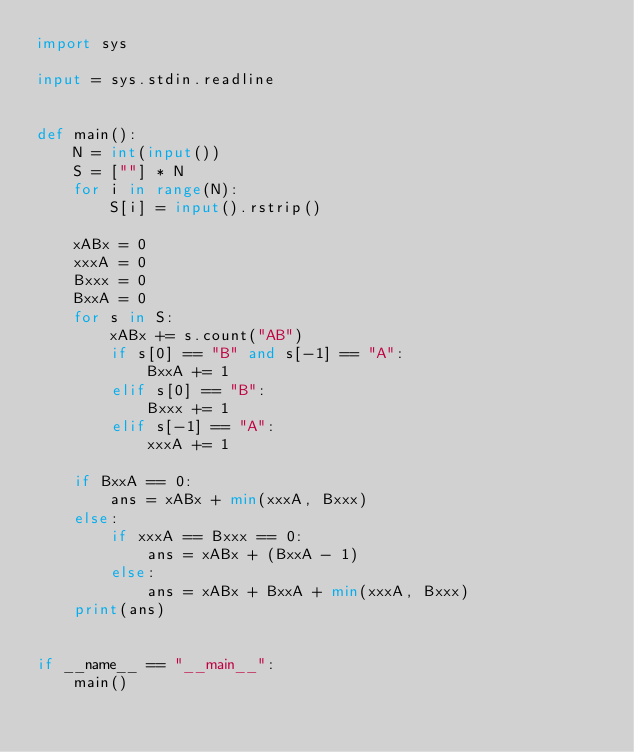<code> <loc_0><loc_0><loc_500><loc_500><_Python_>import sys

input = sys.stdin.readline


def main():
    N = int(input())
    S = [""] * N
    for i in range(N):
        S[i] = input().rstrip()

    xABx = 0
    xxxA = 0
    Bxxx = 0
    BxxA = 0
    for s in S:
        xABx += s.count("AB")
        if s[0] == "B" and s[-1] == "A":
            BxxA += 1
        elif s[0] == "B":
            Bxxx += 1
        elif s[-1] == "A":
            xxxA += 1

    if BxxA == 0:
        ans = xABx + min(xxxA, Bxxx)
    else:
        if xxxA == Bxxx == 0:
            ans = xABx + (BxxA - 1)
        else:
            ans = xABx + BxxA + min(xxxA, Bxxx)
    print(ans)


if __name__ == "__main__":
    main()
</code> 